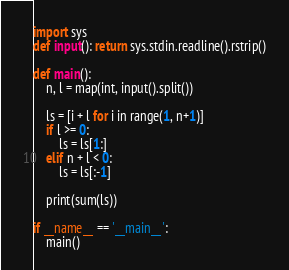Convert code to text. <code><loc_0><loc_0><loc_500><loc_500><_Python_>import sys
def input(): return sys.stdin.readline().rstrip()

def main():
    n, l = map(int, input().split())

    ls = [i + l for i in range(1, n+1)]
    if l >= 0:
        ls = ls[1:]
    elif n + l < 0:
        ls = ls[:-1]

    print(sum(ls))

if __name__ == '__main__':
    main()
</code> 